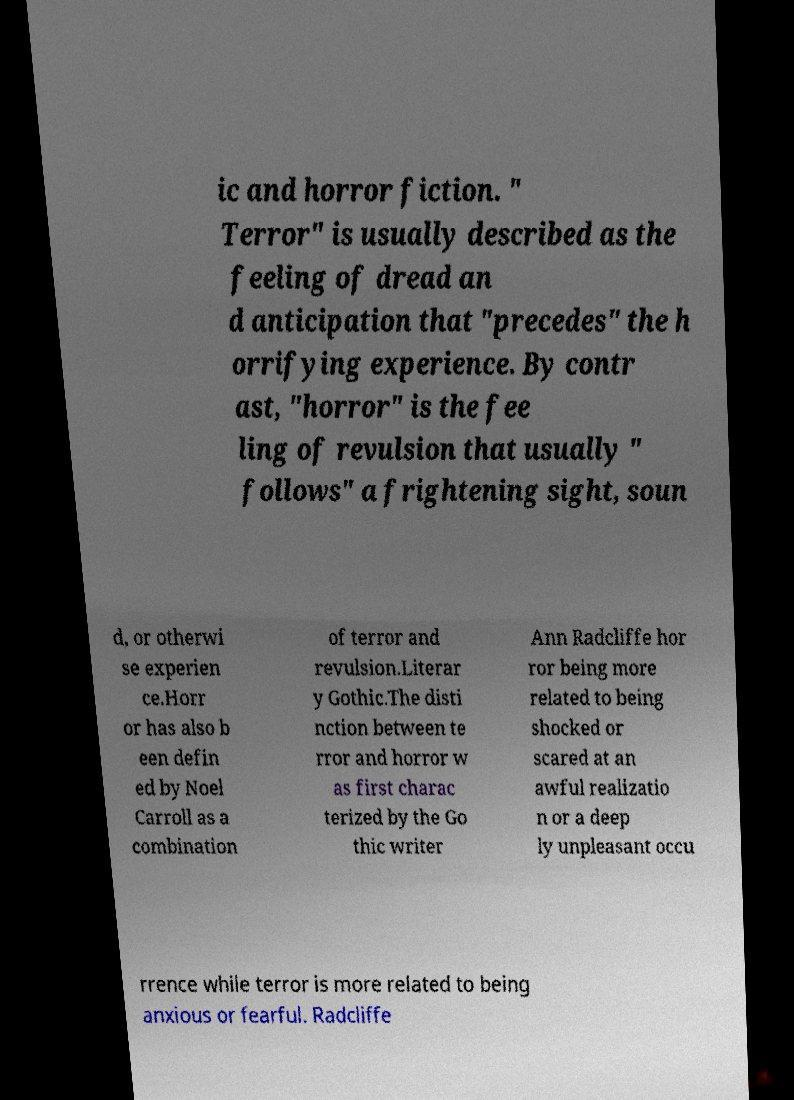Can you accurately transcribe the text from the provided image for me? ic and horror fiction. " Terror" is usually described as the feeling of dread an d anticipation that "precedes" the h orrifying experience. By contr ast, "horror" is the fee ling of revulsion that usually " follows" a frightening sight, soun d, or otherwi se experien ce.Horr or has also b een defin ed by Noel Carroll as a combination of terror and revulsion.Literar y Gothic.The disti nction between te rror and horror w as first charac terized by the Go thic writer Ann Radcliffe hor ror being more related to being shocked or scared at an awful realizatio n or a deep ly unpleasant occu rrence while terror is more related to being anxious or fearful. Radcliffe 